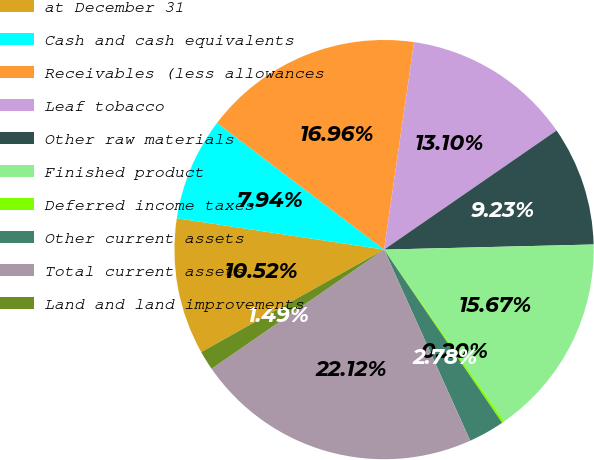Convert chart to OTSL. <chart><loc_0><loc_0><loc_500><loc_500><pie_chart><fcel>at December 31<fcel>Cash and cash equivalents<fcel>Receivables (less allowances<fcel>Leaf tobacco<fcel>Other raw materials<fcel>Finished product<fcel>Deferred income taxes<fcel>Other current assets<fcel>Total current assets<fcel>Land and land improvements<nl><fcel>10.52%<fcel>7.94%<fcel>16.96%<fcel>13.1%<fcel>9.23%<fcel>15.67%<fcel>0.2%<fcel>2.78%<fcel>22.12%<fcel>1.49%<nl></chart> 